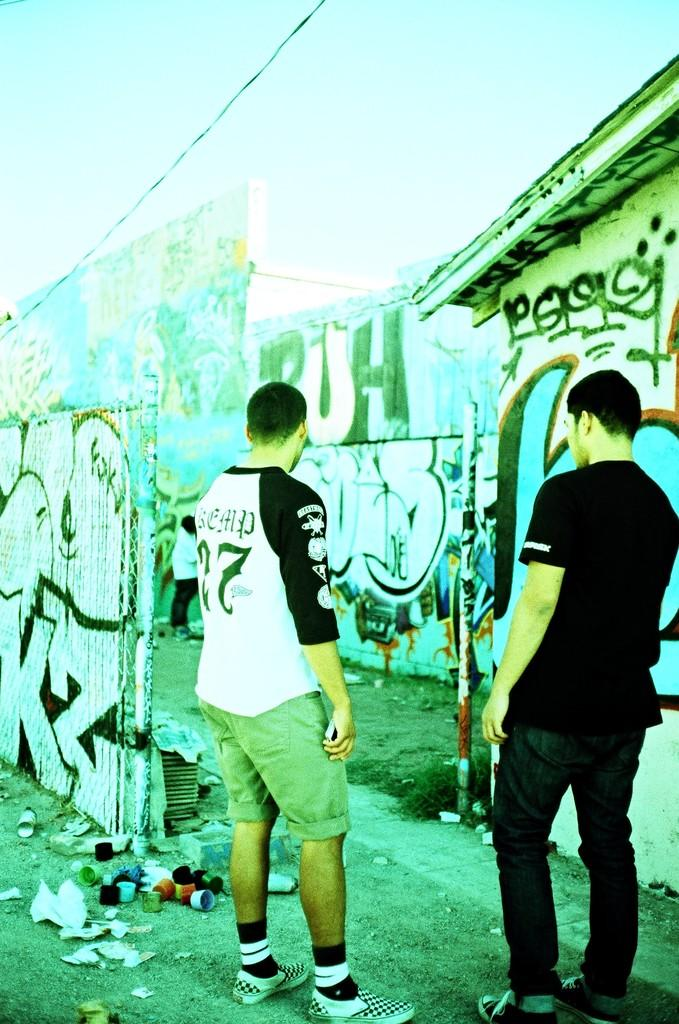How many people are in the image? There are two men in the image. What are the men doing in the image? The men are standing on the ground. What objects can be seen on the ground in the image? There are caps and a bottle of paint spray on the ground. What is the condition of the walls in the image? The walls in the image are painted. What type of authority figure can be seen in the image? There is no authority figure present in the image. How many patches are visible on the walls in the image? The walls in the image are painted, but there is no mention of patches. 